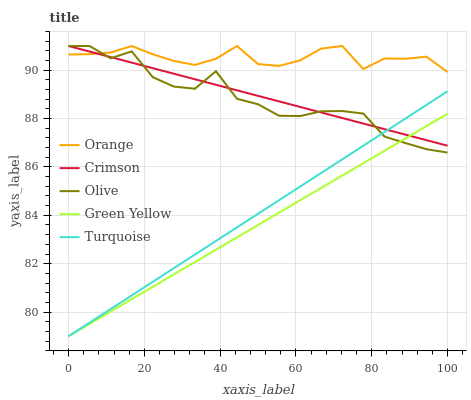Does Green Yellow have the minimum area under the curve?
Answer yes or no. Yes. Does Orange have the maximum area under the curve?
Answer yes or no. Yes. Does Crimson have the minimum area under the curve?
Answer yes or no. No. Does Crimson have the maximum area under the curve?
Answer yes or no. No. Is Turquoise the smoothest?
Answer yes or no. Yes. Is Olive the roughest?
Answer yes or no. Yes. Is Crimson the smoothest?
Answer yes or no. No. Is Crimson the roughest?
Answer yes or no. No. Does Crimson have the lowest value?
Answer yes or no. No. Does Turquoise have the highest value?
Answer yes or no. No. Is Turquoise less than Orange?
Answer yes or no. Yes. Is Orange greater than Turquoise?
Answer yes or no. Yes. Does Turquoise intersect Orange?
Answer yes or no. No. 